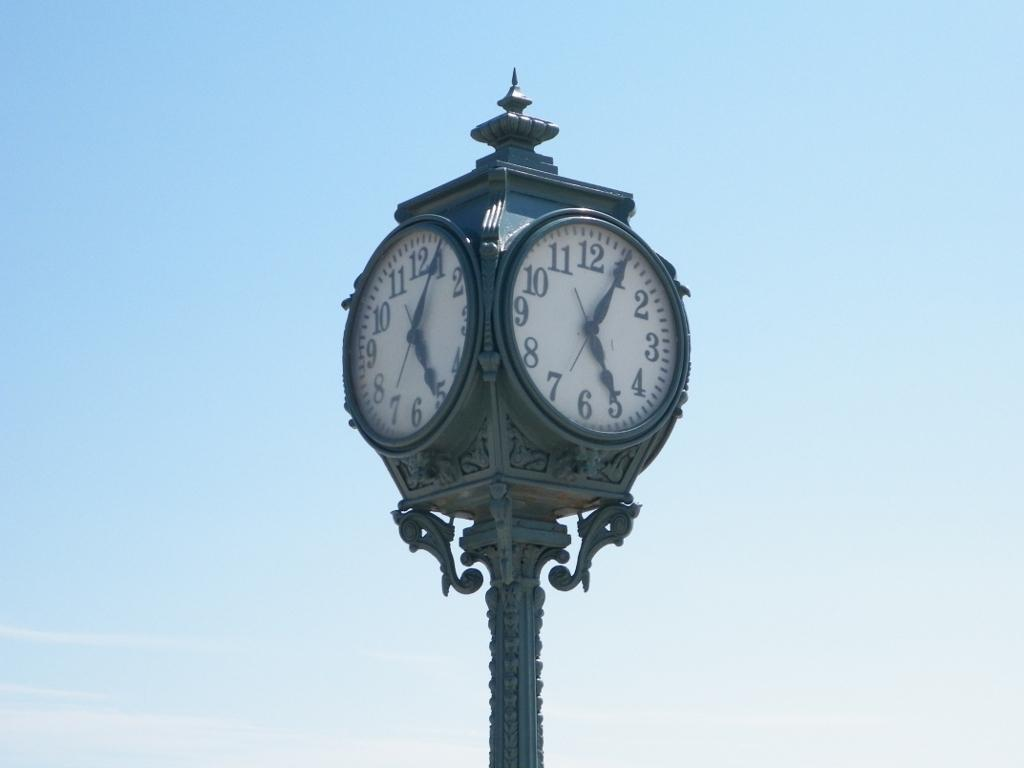<image>
Relay a brief, clear account of the picture shown. An ornate 4 sided clock displaying the time 5:05. 